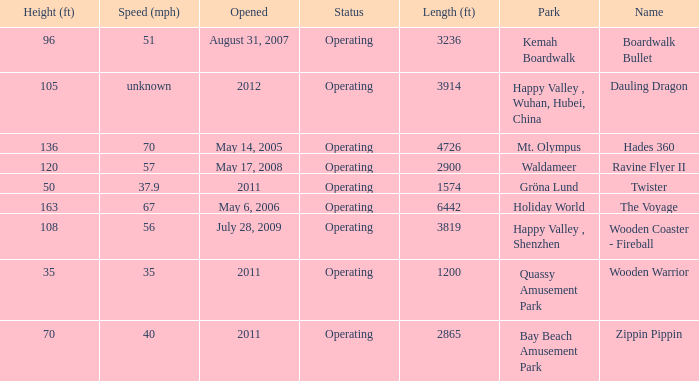In how many parks does zippin pippin exist? 1.0. 